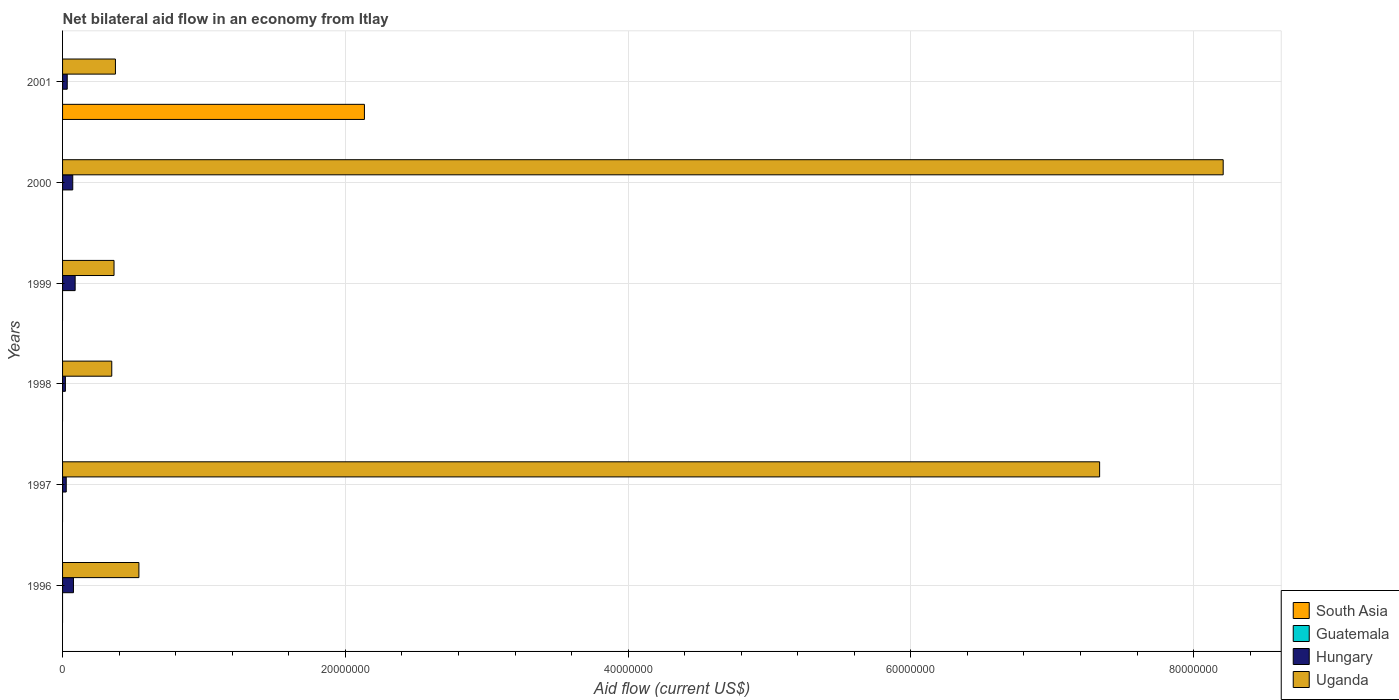How many different coloured bars are there?
Ensure brevity in your answer.  3. How many groups of bars are there?
Make the answer very short. 6. Are the number of bars on each tick of the Y-axis equal?
Offer a terse response. No. How many bars are there on the 3rd tick from the top?
Your response must be concise. 2. How many bars are there on the 2nd tick from the bottom?
Offer a terse response. 2. What is the label of the 6th group of bars from the top?
Offer a terse response. 1996. What is the net bilateral aid flow in Uganda in 1996?
Ensure brevity in your answer.  5.40e+06. Across all years, what is the maximum net bilateral aid flow in South Asia?
Your response must be concise. 2.14e+07. What is the total net bilateral aid flow in South Asia in the graph?
Your response must be concise. 2.14e+07. What is the difference between the net bilateral aid flow in Hungary in 1999 and that in 2001?
Your answer should be very brief. 5.60e+05. What is the difference between the net bilateral aid flow in Guatemala in 1998 and the net bilateral aid flow in South Asia in 2001?
Your answer should be very brief. -2.14e+07. What is the average net bilateral aid flow in South Asia per year?
Ensure brevity in your answer.  3.56e+06. In the year 1996, what is the difference between the net bilateral aid flow in Hungary and net bilateral aid flow in Uganda?
Keep it short and to the point. -4.63e+06. In how many years, is the net bilateral aid flow in Hungary greater than 48000000 US$?
Your answer should be very brief. 0. What is the ratio of the net bilateral aid flow in Uganda in 1996 to that in 1999?
Offer a terse response. 1.48. Is the net bilateral aid flow in Hungary in 1997 less than that in 2001?
Offer a very short reply. Yes. Is the difference between the net bilateral aid flow in Hungary in 1998 and 2000 greater than the difference between the net bilateral aid flow in Uganda in 1998 and 2000?
Provide a short and direct response. Yes. What is the difference between the highest and the second highest net bilateral aid flow in Uganda?
Your answer should be compact. 8.74e+06. What is the difference between the highest and the lowest net bilateral aid flow in Uganda?
Keep it short and to the point. 7.86e+07. How many years are there in the graph?
Provide a short and direct response. 6. Does the graph contain any zero values?
Ensure brevity in your answer.  Yes. Where does the legend appear in the graph?
Provide a succinct answer. Bottom right. What is the title of the graph?
Your answer should be compact. Net bilateral aid flow in an economy from Itlay. What is the label or title of the Y-axis?
Your answer should be very brief. Years. What is the Aid flow (current US$) in Hungary in 1996?
Your answer should be very brief. 7.70e+05. What is the Aid flow (current US$) in Uganda in 1996?
Keep it short and to the point. 5.40e+06. What is the Aid flow (current US$) in South Asia in 1997?
Your answer should be compact. 0. What is the Aid flow (current US$) of Guatemala in 1997?
Keep it short and to the point. 0. What is the Aid flow (current US$) of Uganda in 1997?
Your answer should be compact. 7.34e+07. What is the Aid flow (current US$) of Guatemala in 1998?
Ensure brevity in your answer.  0. What is the Aid flow (current US$) in Uganda in 1998?
Provide a succinct answer. 3.48e+06. What is the Aid flow (current US$) in Guatemala in 1999?
Ensure brevity in your answer.  0. What is the Aid flow (current US$) in Hungary in 1999?
Offer a very short reply. 8.90e+05. What is the Aid flow (current US$) in Uganda in 1999?
Keep it short and to the point. 3.64e+06. What is the Aid flow (current US$) in Guatemala in 2000?
Give a very brief answer. 0. What is the Aid flow (current US$) of Hungary in 2000?
Offer a terse response. 7.20e+05. What is the Aid flow (current US$) in Uganda in 2000?
Give a very brief answer. 8.21e+07. What is the Aid flow (current US$) in South Asia in 2001?
Keep it short and to the point. 2.14e+07. What is the Aid flow (current US$) of Guatemala in 2001?
Offer a very short reply. 0. What is the Aid flow (current US$) in Uganda in 2001?
Make the answer very short. 3.74e+06. Across all years, what is the maximum Aid flow (current US$) of South Asia?
Your answer should be compact. 2.14e+07. Across all years, what is the maximum Aid flow (current US$) of Hungary?
Give a very brief answer. 8.90e+05. Across all years, what is the maximum Aid flow (current US$) of Uganda?
Ensure brevity in your answer.  8.21e+07. Across all years, what is the minimum Aid flow (current US$) of Uganda?
Give a very brief answer. 3.48e+06. What is the total Aid flow (current US$) in South Asia in the graph?
Provide a succinct answer. 2.14e+07. What is the total Aid flow (current US$) of Guatemala in the graph?
Provide a succinct answer. 0. What is the total Aid flow (current US$) in Hungary in the graph?
Make the answer very short. 3.17e+06. What is the total Aid flow (current US$) in Uganda in the graph?
Offer a very short reply. 1.72e+08. What is the difference between the Aid flow (current US$) in Hungary in 1996 and that in 1997?
Your answer should be compact. 5.10e+05. What is the difference between the Aid flow (current US$) in Uganda in 1996 and that in 1997?
Make the answer very short. -6.80e+07. What is the difference between the Aid flow (current US$) in Hungary in 1996 and that in 1998?
Make the answer very short. 5.70e+05. What is the difference between the Aid flow (current US$) of Uganda in 1996 and that in 1998?
Provide a succinct answer. 1.92e+06. What is the difference between the Aid flow (current US$) of Uganda in 1996 and that in 1999?
Provide a succinct answer. 1.76e+06. What is the difference between the Aid flow (current US$) of Uganda in 1996 and that in 2000?
Your response must be concise. -7.67e+07. What is the difference between the Aid flow (current US$) of Uganda in 1996 and that in 2001?
Ensure brevity in your answer.  1.66e+06. What is the difference between the Aid flow (current US$) in Hungary in 1997 and that in 1998?
Offer a very short reply. 6.00e+04. What is the difference between the Aid flow (current US$) in Uganda in 1997 and that in 1998?
Your answer should be compact. 6.99e+07. What is the difference between the Aid flow (current US$) in Hungary in 1997 and that in 1999?
Ensure brevity in your answer.  -6.30e+05. What is the difference between the Aid flow (current US$) of Uganda in 1997 and that in 1999?
Provide a short and direct response. 6.97e+07. What is the difference between the Aid flow (current US$) of Hungary in 1997 and that in 2000?
Your answer should be compact. -4.60e+05. What is the difference between the Aid flow (current US$) in Uganda in 1997 and that in 2000?
Keep it short and to the point. -8.74e+06. What is the difference between the Aid flow (current US$) in Hungary in 1997 and that in 2001?
Your answer should be very brief. -7.00e+04. What is the difference between the Aid flow (current US$) of Uganda in 1997 and that in 2001?
Provide a succinct answer. 6.96e+07. What is the difference between the Aid flow (current US$) in Hungary in 1998 and that in 1999?
Ensure brevity in your answer.  -6.90e+05. What is the difference between the Aid flow (current US$) in Hungary in 1998 and that in 2000?
Give a very brief answer. -5.20e+05. What is the difference between the Aid flow (current US$) of Uganda in 1998 and that in 2000?
Offer a terse response. -7.86e+07. What is the difference between the Aid flow (current US$) of Hungary in 1998 and that in 2001?
Your response must be concise. -1.30e+05. What is the difference between the Aid flow (current US$) in Uganda in 1999 and that in 2000?
Your answer should be compact. -7.84e+07. What is the difference between the Aid flow (current US$) in Hungary in 1999 and that in 2001?
Your answer should be compact. 5.60e+05. What is the difference between the Aid flow (current US$) in Uganda in 2000 and that in 2001?
Keep it short and to the point. 7.84e+07. What is the difference between the Aid flow (current US$) in Hungary in 1996 and the Aid flow (current US$) in Uganda in 1997?
Your response must be concise. -7.26e+07. What is the difference between the Aid flow (current US$) in Hungary in 1996 and the Aid flow (current US$) in Uganda in 1998?
Give a very brief answer. -2.71e+06. What is the difference between the Aid flow (current US$) in Hungary in 1996 and the Aid flow (current US$) in Uganda in 1999?
Keep it short and to the point. -2.87e+06. What is the difference between the Aid flow (current US$) in Hungary in 1996 and the Aid flow (current US$) in Uganda in 2000?
Make the answer very short. -8.13e+07. What is the difference between the Aid flow (current US$) of Hungary in 1996 and the Aid flow (current US$) of Uganda in 2001?
Ensure brevity in your answer.  -2.97e+06. What is the difference between the Aid flow (current US$) in Hungary in 1997 and the Aid flow (current US$) in Uganda in 1998?
Keep it short and to the point. -3.22e+06. What is the difference between the Aid flow (current US$) in Hungary in 1997 and the Aid flow (current US$) in Uganda in 1999?
Offer a very short reply. -3.38e+06. What is the difference between the Aid flow (current US$) in Hungary in 1997 and the Aid flow (current US$) in Uganda in 2000?
Ensure brevity in your answer.  -8.18e+07. What is the difference between the Aid flow (current US$) in Hungary in 1997 and the Aid flow (current US$) in Uganda in 2001?
Provide a succinct answer. -3.48e+06. What is the difference between the Aid flow (current US$) of Hungary in 1998 and the Aid flow (current US$) of Uganda in 1999?
Offer a very short reply. -3.44e+06. What is the difference between the Aid flow (current US$) of Hungary in 1998 and the Aid flow (current US$) of Uganda in 2000?
Ensure brevity in your answer.  -8.19e+07. What is the difference between the Aid flow (current US$) of Hungary in 1998 and the Aid flow (current US$) of Uganda in 2001?
Provide a short and direct response. -3.54e+06. What is the difference between the Aid flow (current US$) in Hungary in 1999 and the Aid flow (current US$) in Uganda in 2000?
Keep it short and to the point. -8.12e+07. What is the difference between the Aid flow (current US$) in Hungary in 1999 and the Aid flow (current US$) in Uganda in 2001?
Make the answer very short. -2.85e+06. What is the difference between the Aid flow (current US$) in Hungary in 2000 and the Aid flow (current US$) in Uganda in 2001?
Provide a succinct answer. -3.02e+06. What is the average Aid flow (current US$) of South Asia per year?
Offer a terse response. 3.56e+06. What is the average Aid flow (current US$) of Hungary per year?
Your answer should be very brief. 5.28e+05. What is the average Aid flow (current US$) of Uganda per year?
Provide a short and direct response. 2.86e+07. In the year 1996, what is the difference between the Aid flow (current US$) in Hungary and Aid flow (current US$) in Uganda?
Offer a very short reply. -4.63e+06. In the year 1997, what is the difference between the Aid flow (current US$) of Hungary and Aid flow (current US$) of Uganda?
Your answer should be very brief. -7.31e+07. In the year 1998, what is the difference between the Aid flow (current US$) in Hungary and Aid flow (current US$) in Uganda?
Your answer should be very brief. -3.28e+06. In the year 1999, what is the difference between the Aid flow (current US$) of Hungary and Aid flow (current US$) of Uganda?
Your response must be concise. -2.75e+06. In the year 2000, what is the difference between the Aid flow (current US$) in Hungary and Aid flow (current US$) in Uganda?
Your answer should be very brief. -8.14e+07. In the year 2001, what is the difference between the Aid flow (current US$) of South Asia and Aid flow (current US$) of Hungary?
Provide a succinct answer. 2.10e+07. In the year 2001, what is the difference between the Aid flow (current US$) in South Asia and Aid flow (current US$) in Uganda?
Offer a very short reply. 1.76e+07. In the year 2001, what is the difference between the Aid flow (current US$) in Hungary and Aid flow (current US$) in Uganda?
Offer a terse response. -3.41e+06. What is the ratio of the Aid flow (current US$) in Hungary in 1996 to that in 1997?
Your answer should be very brief. 2.96. What is the ratio of the Aid flow (current US$) in Uganda in 1996 to that in 1997?
Provide a short and direct response. 0.07. What is the ratio of the Aid flow (current US$) of Hungary in 1996 to that in 1998?
Provide a succinct answer. 3.85. What is the ratio of the Aid flow (current US$) in Uganda in 1996 to that in 1998?
Make the answer very short. 1.55. What is the ratio of the Aid flow (current US$) in Hungary in 1996 to that in 1999?
Make the answer very short. 0.87. What is the ratio of the Aid flow (current US$) of Uganda in 1996 to that in 1999?
Offer a very short reply. 1.48. What is the ratio of the Aid flow (current US$) of Hungary in 1996 to that in 2000?
Your response must be concise. 1.07. What is the ratio of the Aid flow (current US$) of Uganda in 1996 to that in 2000?
Offer a very short reply. 0.07. What is the ratio of the Aid flow (current US$) of Hungary in 1996 to that in 2001?
Offer a terse response. 2.33. What is the ratio of the Aid flow (current US$) of Uganda in 1996 to that in 2001?
Give a very brief answer. 1.44. What is the ratio of the Aid flow (current US$) in Uganda in 1997 to that in 1998?
Offer a very short reply. 21.08. What is the ratio of the Aid flow (current US$) of Hungary in 1997 to that in 1999?
Ensure brevity in your answer.  0.29. What is the ratio of the Aid flow (current US$) of Uganda in 1997 to that in 1999?
Make the answer very short. 20.15. What is the ratio of the Aid flow (current US$) in Hungary in 1997 to that in 2000?
Your answer should be compact. 0.36. What is the ratio of the Aid flow (current US$) in Uganda in 1997 to that in 2000?
Offer a very short reply. 0.89. What is the ratio of the Aid flow (current US$) in Hungary in 1997 to that in 2001?
Offer a terse response. 0.79. What is the ratio of the Aid flow (current US$) of Uganda in 1997 to that in 2001?
Keep it short and to the point. 19.61. What is the ratio of the Aid flow (current US$) in Hungary in 1998 to that in 1999?
Keep it short and to the point. 0.22. What is the ratio of the Aid flow (current US$) in Uganda in 1998 to that in 1999?
Keep it short and to the point. 0.96. What is the ratio of the Aid flow (current US$) of Hungary in 1998 to that in 2000?
Make the answer very short. 0.28. What is the ratio of the Aid flow (current US$) of Uganda in 1998 to that in 2000?
Your answer should be very brief. 0.04. What is the ratio of the Aid flow (current US$) of Hungary in 1998 to that in 2001?
Ensure brevity in your answer.  0.61. What is the ratio of the Aid flow (current US$) of Uganda in 1998 to that in 2001?
Offer a very short reply. 0.93. What is the ratio of the Aid flow (current US$) in Hungary in 1999 to that in 2000?
Provide a succinct answer. 1.24. What is the ratio of the Aid flow (current US$) in Uganda in 1999 to that in 2000?
Your answer should be very brief. 0.04. What is the ratio of the Aid flow (current US$) of Hungary in 1999 to that in 2001?
Make the answer very short. 2.7. What is the ratio of the Aid flow (current US$) of Uganda in 1999 to that in 2001?
Offer a very short reply. 0.97. What is the ratio of the Aid flow (current US$) of Hungary in 2000 to that in 2001?
Provide a short and direct response. 2.18. What is the ratio of the Aid flow (current US$) in Uganda in 2000 to that in 2001?
Offer a terse response. 21.95. What is the difference between the highest and the second highest Aid flow (current US$) of Uganda?
Provide a short and direct response. 8.74e+06. What is the difference between the highest and the lowest Aid flow (current US$) in South Asia?
Keep it short and to the point. 2.14e+07. What is the difference between the highest and the lowest Aid flow (current US$) in Hungary?
Keep it short and to the point. 6.90e+05. What is the difference between the highest and the lowest Aid flow (current US$) of Uganda?
Keep it short and to the point. 7.86e+07. 